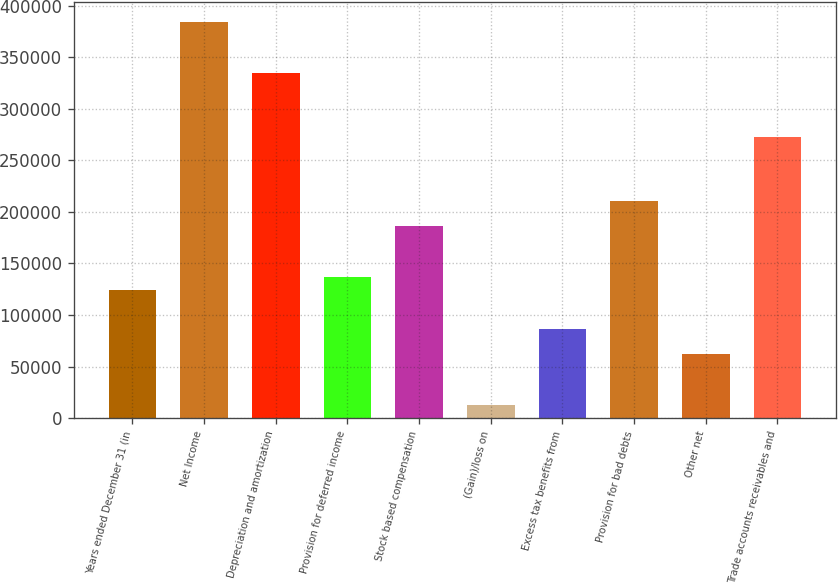<chart> <loc_0><loc_0><loc_500><loc_500><bar_chart><fcel>Years ended December 31 (in<fcel>Net Income<fcel>Depreciation and amortization<fcel>Provision for deferred income<fcel>Stock based compensation<fcel>(Gain)/loss on<fcel>Excess tax benefits from<fcel>Provision for bad debts<fcel>Other net<fcel>Trade accounts receivables and<nl><fcel>124053<fcel>384550<fcel>334931<fcel>136458<fcel>186076<fcel>12411.6<fcel>86839.2<fcel>210885<fcel>62030<fcel>272908<nl></chart> 